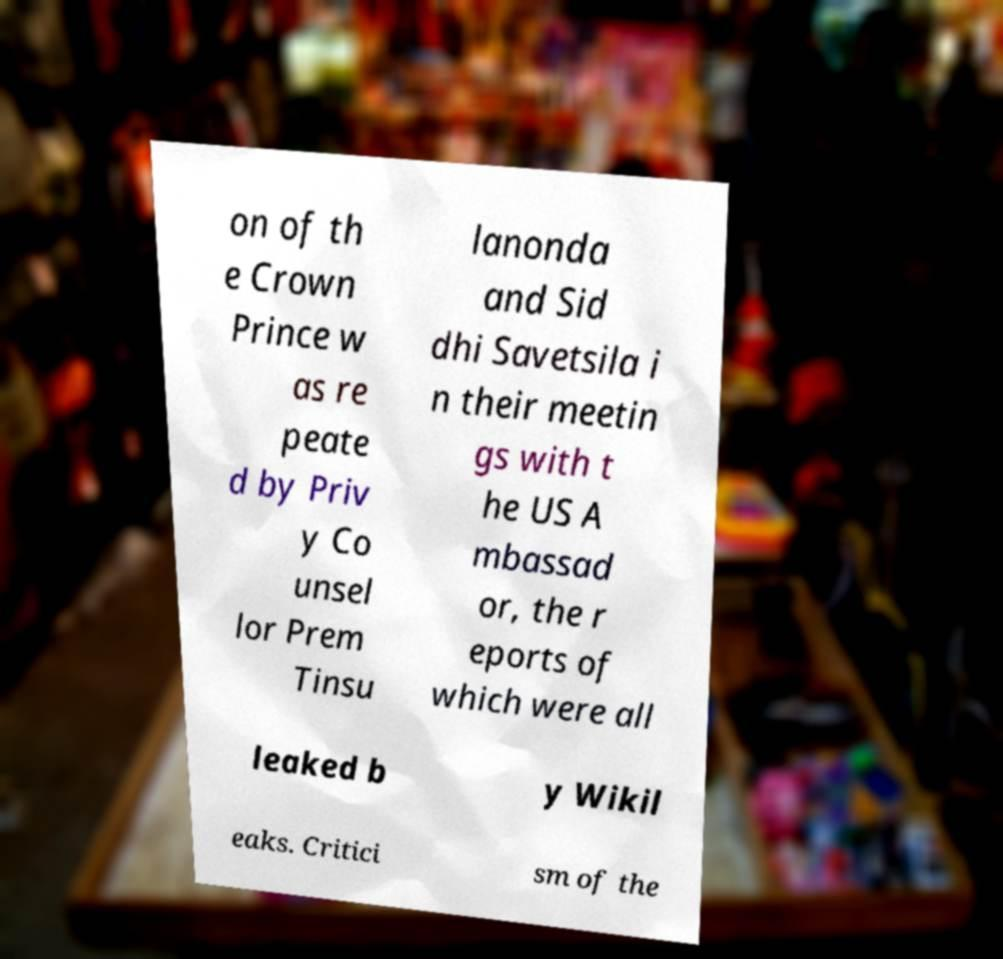Could you extract and type out the text from this image? on of th e Crown Prince w as re peate d by Priv y Co unsel lor Prem Tinsu lanonda and Sid dhi Savetsila i n their meetin gs with t he US A mbassad or, the r eports of which were all leaked b y Wikil eaks. Critici sm of the 